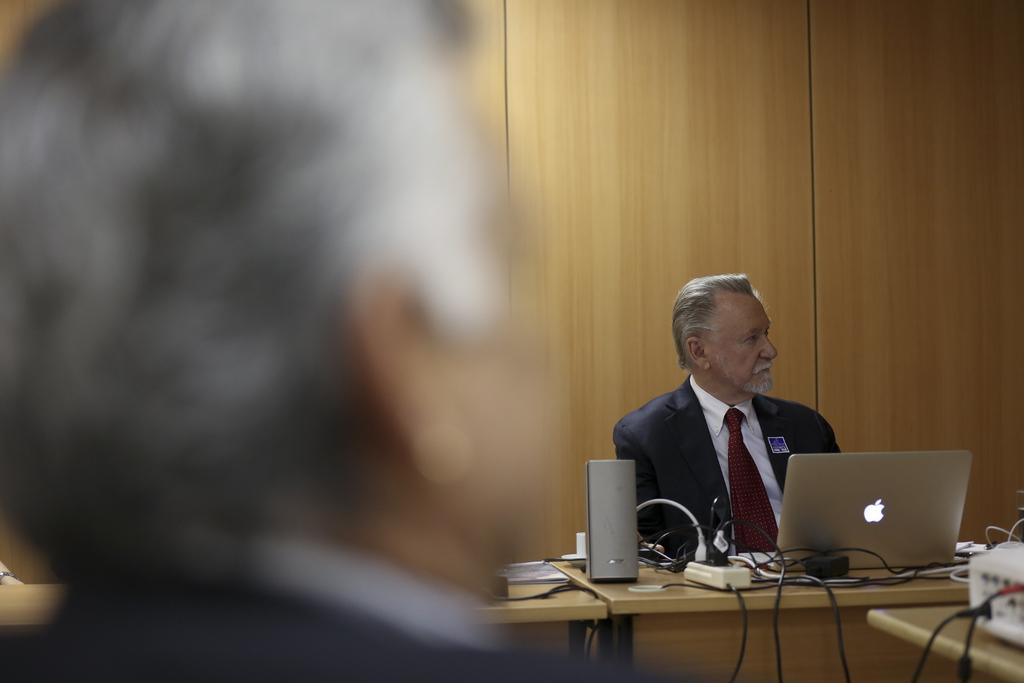Who is present in the image? There is a man in the image. What is the man doing in the image? The man is sitting on a chair. What objects can be seen on the table in the image? There is a laptop, cables, and a book on the table. What is visible in the background of the image? There is a wall in the background of the image. What type of pie is the man eating in the image? There is no pie present in the image; the man is sitting on a chair and there is a laptop, cables, and a book on the table. What sense is the man using to interact with the laptop in the image? The question is not relevant to the image, as it does not mention any sensory interaction with the laptop. 